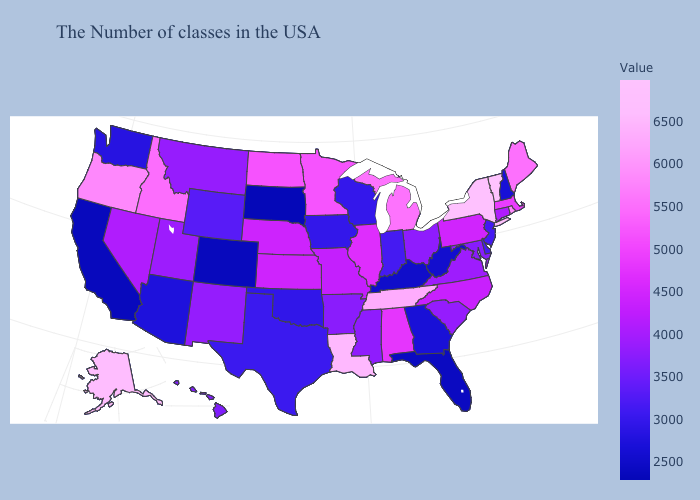Which states hav the highest value in the MidWest?
Quick response, please. Michigan. Does Wisconsin have a lower value than Kentucky?
Concise answer only. No. Which states have the lowest value in the USA?
Keep it brief. South Dakota. Among the states that border West Virginia , which have the highest value?
Be succinct. Pennsylvania. Does Hawaii have the highest value in the West?
Quick response, please. No. Does South Dakota have the lowest value in the USA?
Give a very brief answer. Yes. Among the states that border Arizona , does California have the lowest value?
Be succinct. Yes. Among the states that border West Virginia , does Kentucky have the lowest value?
Give a very brief answer. Yes. 